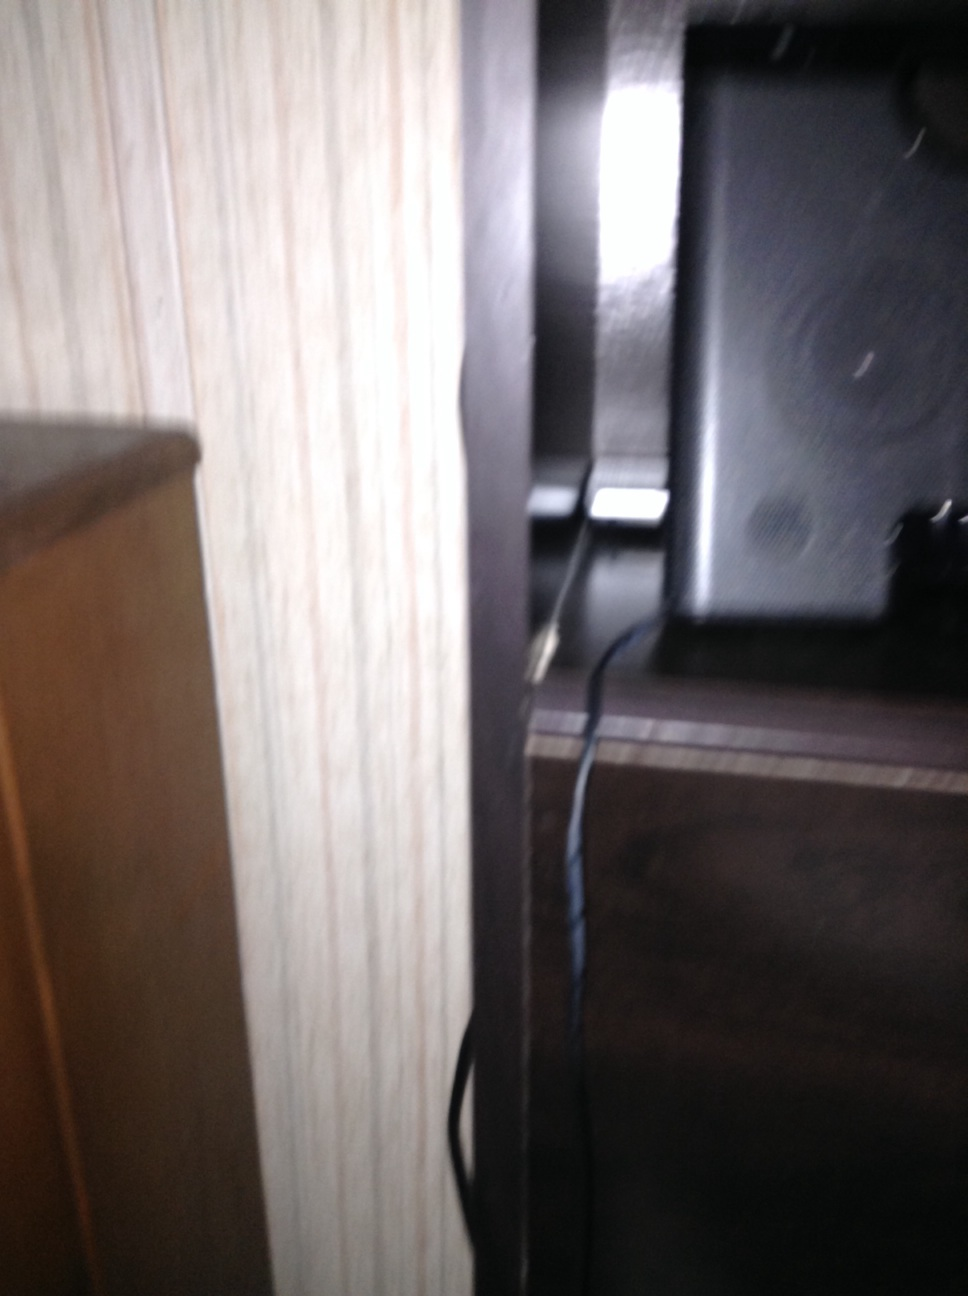Why might there be a speaker positioned in such a way? The speaker might be positioned here to optimize audio quality within the room. This placement allows sound to fill the space more evenly, creating an immersive listening experience. Additionally, placing the speaker near a wall can enhance bass response. 